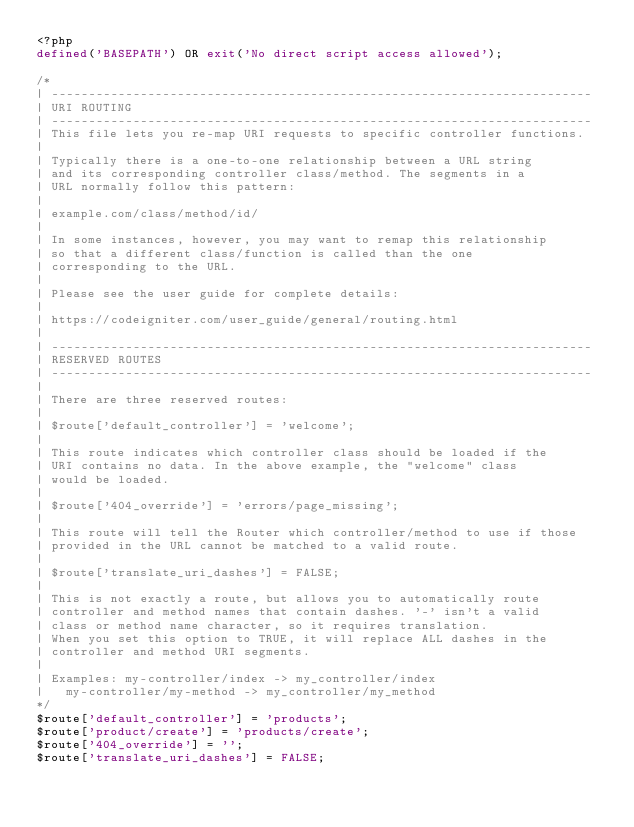Convert code to text. <code><loc_0><loc_0><loc_500><loc_500><_PHP_><?php
defined('BASEPATH') OR exit('No direct script access allowed');

/*
| -------------------------------------------------------------------------
| URI ROUTING
| -------------------------------------------------------------------------
| This file lets you re-map URI requests to specific controller functions.
|
| Typically there is a one-to-one relationship between a URL string
| and its corresponding controller class/method. The segments in a
| URL normally follow this pattern:
|
|	example.com/class/method/id/
|
| In some instances, however, you may want to remap this relationship
| so that a different class/function is called than the one
| corresponding to the URL.
|
| Please see the user guide for complete details:
|
|	https://codeigniter.com/user_guide/general/routing.html
|
| -------------------------------------------------------------------------
| RESERVED ROUTES
| -------------------------------------------------------------------------
|
| There are three reserved routes:
|
|	$route['default_controller'] = 'welcome';
|
| This route indicates which controller class should be loaded if the
| URI contains no data. In the above example, the "welcome" class
| would be loaded.
|
|	$route['404_override'] = 'errors/page_missing';
|
| This route will tell the Router which controller/method to use if those
| provided in the URL cannot be matched to a valid route.
|
|	$route['translate_uri_dashes'] = FALSE;
|
| This is not exactly a route, but allows you to automatically route
| controller and method names that contain dashes. '-' isn't a valid
| class or method name character, so it requires translation.
| When you set this option to TRUE, it will replace ALL dashes in the
| controller and method URI segments.
|
| Examples:	my-controller/index	-> my_controller/index
|		my-controller/my-method	-> my_controller/my_method
*/
$route['default_controller'] = 'products';
$route['product/create'] = 'products/create';
$route['404_override'] = '';
$route['translate_uri_dashes'] = FALSE;
</code> 